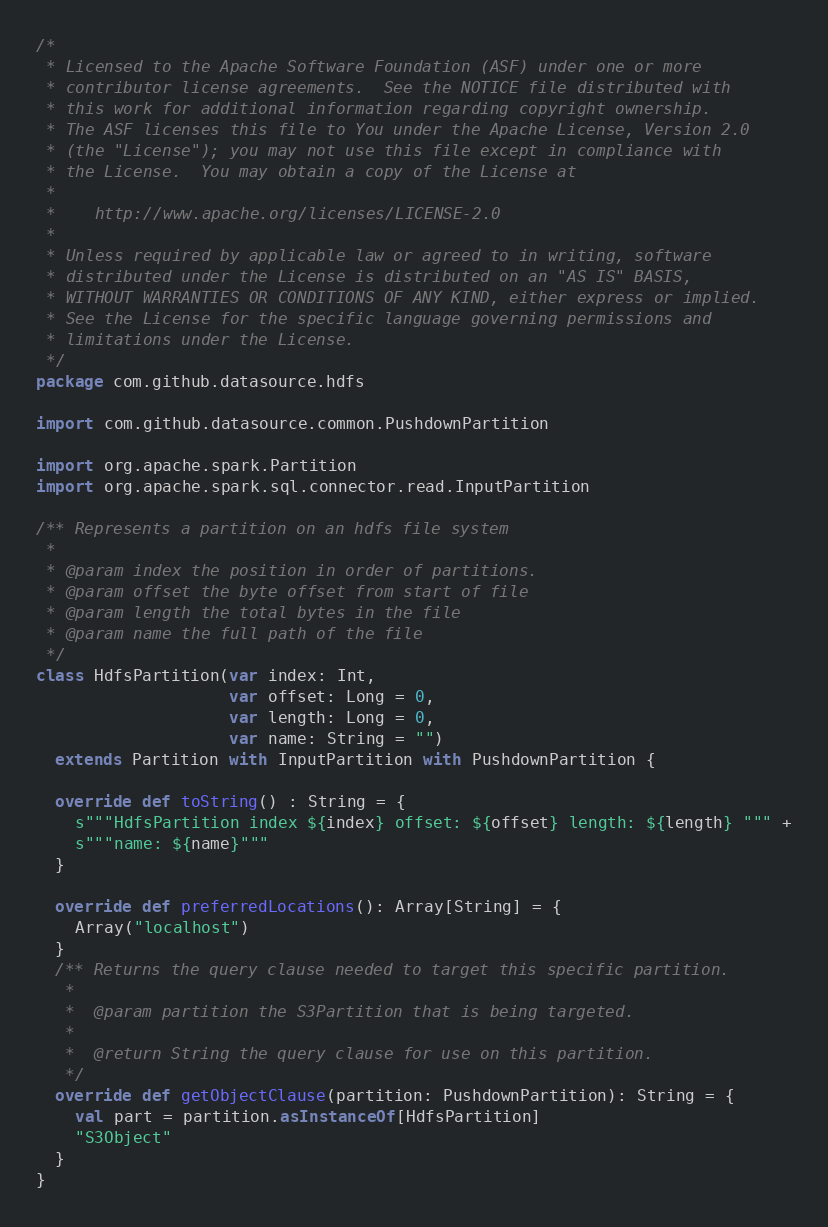Convert code to text. <code><loc_0><loc_0><loc_500><loc_500><_Scala_>/*
 * Licensed to the Apache Software Foundation (ASF) under one or more
 * contributor license agreements.  See the NOTICE file distributed with
 * this work for additional information regarding copyright ownership.
 * The ASF licenses this file to You under the Apache License, Version 2.0
 * (the "License"); you may not use this file except in compliance with
 * the License.  You may obtain a copy of the License at
 *
 *    http://www.apache.org/licenses/LICENSE-2.0
 *
 * Unless required by applicable law or agreed to in writing, software
 * distributed under the License is distributed on an "AS IS" BASIS,
 * WITHOUT WARRANTIES OR CONDITIONS OF ANY KIND, either express or implied.
 * See the License for the specific language governing permissions and
 * limitations under the License.
 */
package com.github.datasource.hdfs

import com.github.datasource.common.PushdownPartition

import org.apache.spark.Partition
import org.apache.spark.sql.connector.read.InputPartition

/** Represents a partition on an hdfs file system
 *
 * @param index the position in order of partitions.
 * @param offset the byte offset from start of file
 * @param length the total bytes in the file
 * @param name the full path of the file
 */
class HdfsPartition(var index: Int,
                    var offset: Long = 0,
                    var length: Long = 0,
                    var name: String = "")
  extends Partition with InputPartition with PushdownPartition {

  override def toString() : String = {
    s"""HdfsPartition index ${index} offset: ${offset} length: ${length} """ +
    s"""name: ${name}"""
  }

  override def preferredLocations(): Array[String] = {
    Array("localhost")
  }
  /** Returns the query clause needed to target this specific partition.
   *
   *  @param partition the S3Partition that is being targeted.
   *
   *  @return String the query clause for use on this partition.
   */
  override def getObjectClause(partition: PushdownPartition): String = {
    val part = partition.asInstanceOf[HdfsPartition]
    "S3Object"
  }
}
</code> 